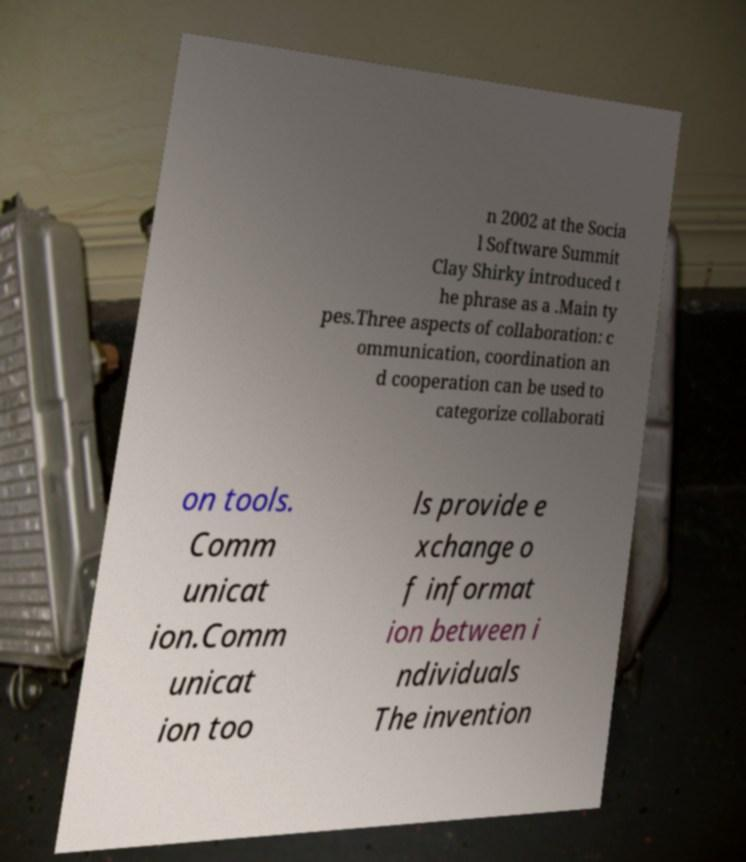Please read and relay the text visible in this image. What does it say? n 2002 at the Socia l Software Summit Clay Shirky introduced t he phrase as a .Main ty pes.Three aspects of collaboration: c ommunication, coordination an d cooperation can be used to categorize collaborati on tools. Comm unicat ion.Comm unicat ion too ls provide e xchange o f informat ion between i ndividuals The invention 